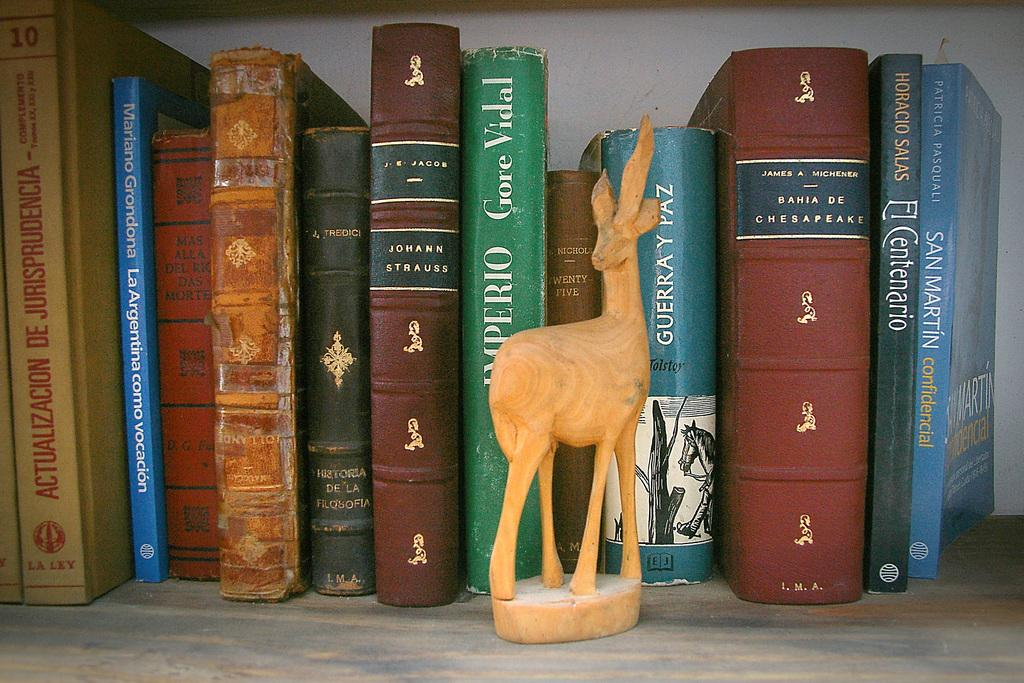<image>
Render a clear and concise summary of the photo. A deer book end in front of a book by Gore Vidal on a shelf full of books. 